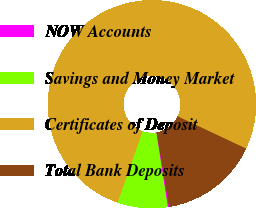<chart> <loc_0><loc_0><loc_500><loc_500><pie_chart><fcel>NOW Accounts<fcel>Savings and Money Market<fcel>Certificates of Deposit<fcel>Total Bank Deposits<nl><fcel>0.22%<fcel>7.78%<fcel>76.67%<fcel>15.33%<nl></chart> 